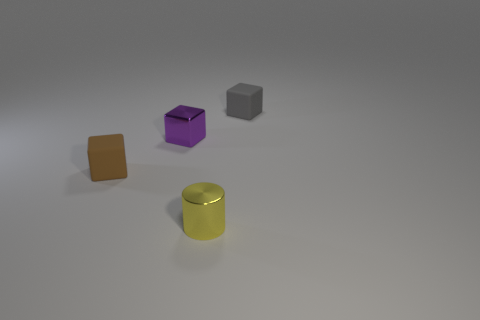Add 3 big blue things. How many objects exist? 7 Subtract all cylinders. How many objects are left? 3 Add 2 small gray rubber things. How many small gray rubber things are left? 3 Add 2 small brown things. How many small brown things exist? 3 Subtract 0 cyan blocks. How many objects are left? 4 Subtract all tiny metallic cylinders. Subtract all matte blocks. How many objects are left? 1 